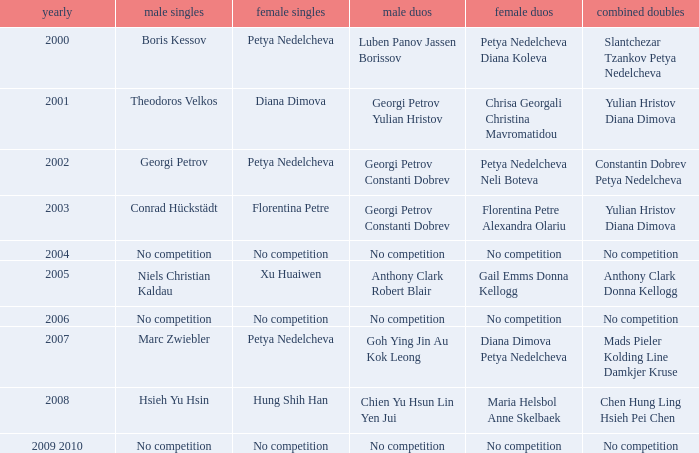Help me parse the entirety of this table. {'header': ['yearly', 'male singles', 'female singles', 'male duos', 'female duos', 'combined doubles'], 'rows': [['2000', 'Boris Kessov', 'Petya Nedelcheva', 'Luben Panov Jassen Borissov', 'Petya Nedelcheva Diana Koleva', 'Slantchezar Tzankov Petya Nedelcheva'], ['2001', 'Theodoros Velkos', 'Diana Dimova', 'Georgi Petrov Yulian Hristov', 'Chrisa Georgali Christina Mavromatidou', 'Yulian Hristov Diana Dimova'], ['2002', 'Georgi Petrov', 'Petya Nedelcheva', 'Georgi Petrov Constanti Dobrev', 'Petya Nedelcheva Neli Boteva', 'Constantin Dobrev Petya Nedelcheva'], ['2003', 'Conrad Hückstädt', 'Florentina Petre', 'Georgi Petrov Constanti Dobrev', 'Florentina Petre Alexandra Olariu', 'Yulian Hristov Diana Dimova'], ['2004', 'No competition', 'No competition', 'No competition', 'No competition', 'No competition'], ['2005', 'Niels Christian Kaldau', 'Xu Huaiwen', 'Anthony Clark Robert Blair', 'Gail Emms Donna Kellogg', 'Anthony Clark Donna Kellogg'], ['2006', 'No competition', 'No competition', 'No competition', 'No competition', 'No competition'], ['2007', 'Marc Zwiebler', 'Petya Nedelcheva', 'Goh Ying Jin Au Kok Leong', 'Diana Dimova Petya Nedelcheva', 'Mads Pieler Kolding Line Damkjer Kruse'], ['2008', 'Hsieh Yu Hsin', 'Hung Shih Han', 'Chien Yu Hsun Lin Yen Jui', 'Maria Helsbol Anne Skelbaek', 'Chen Hung Ling Hsieh Pei Chen'], ['2009 2010', 'No competition', 'No competition', 'No competition', 'No competition', 'No competition']]} Who triumphed in the men's double the same year florentina petre claimed victory in the women's singles? Georgi Petrov Constanti Dobrev. 